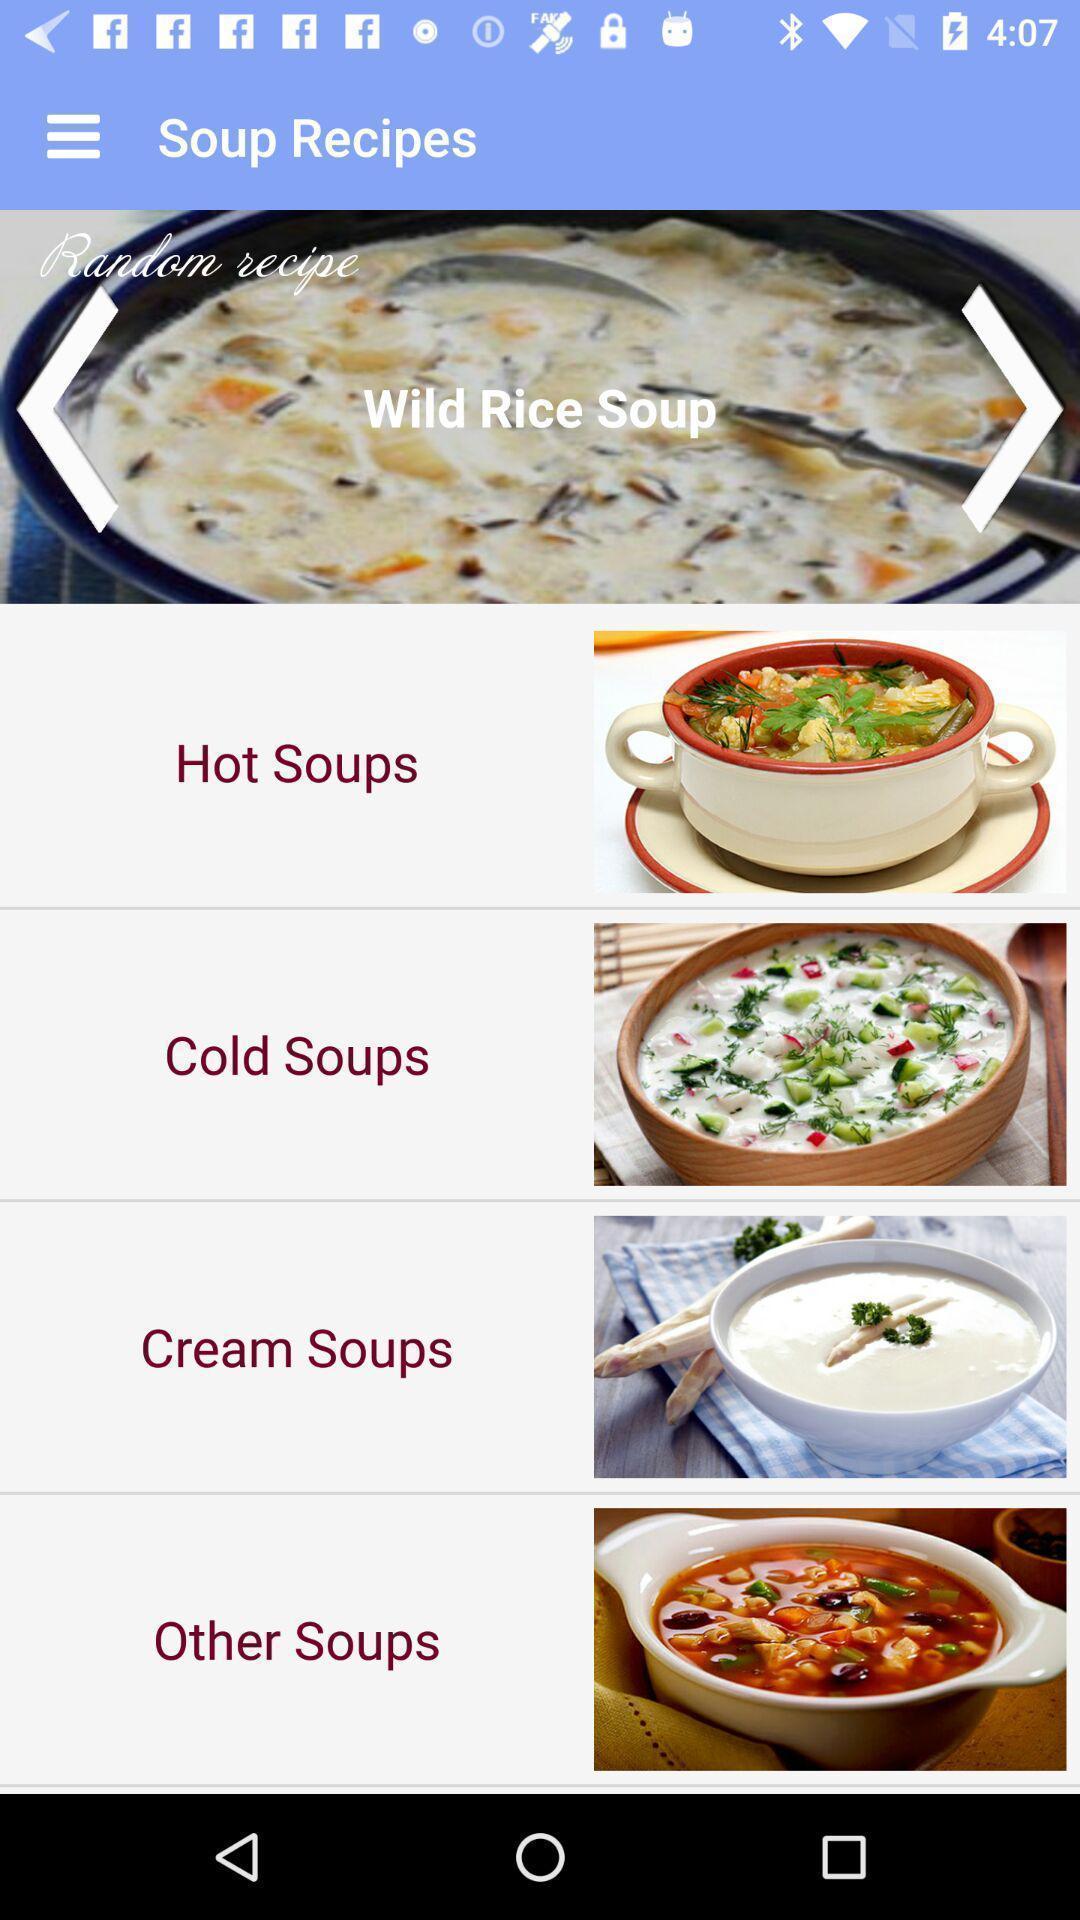Explain what's happening in this screen capture. Screen displaying the options of various soups. 